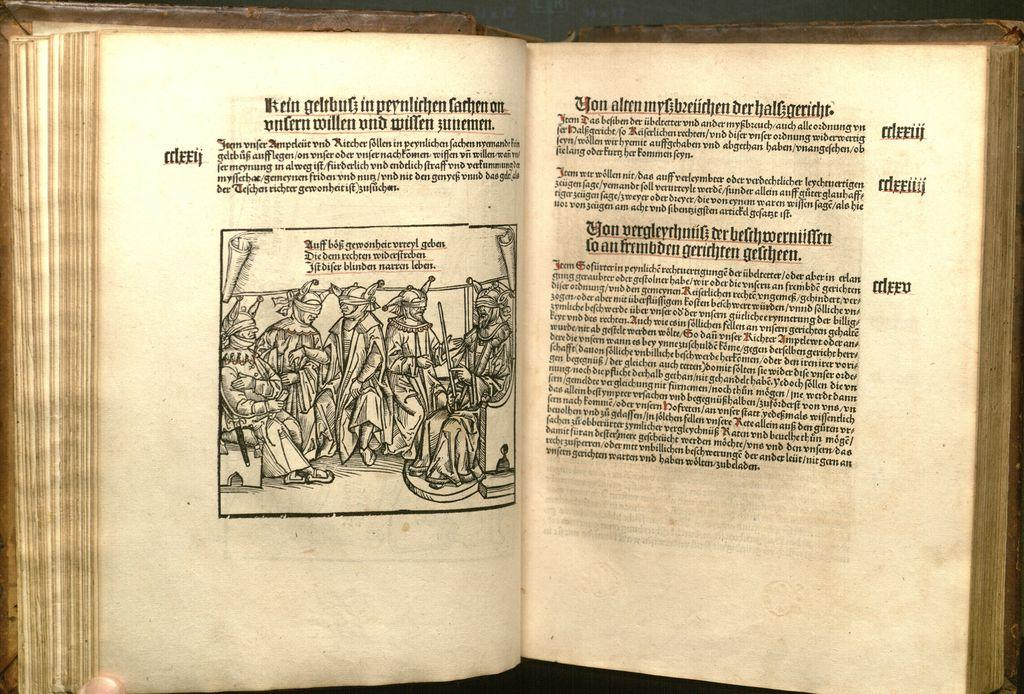What object is present in the image that contains information? There is a book in the image. What can be seen on the paper inside the book? There is an image of people on the paper. What else is present on the paper besides the image? There is writing on the paper. What type of beam is holding up the ceiling in the image? There is no mention of a ceiling or any beams in the image; it only contains a book with an image of people and writing on the paper. 